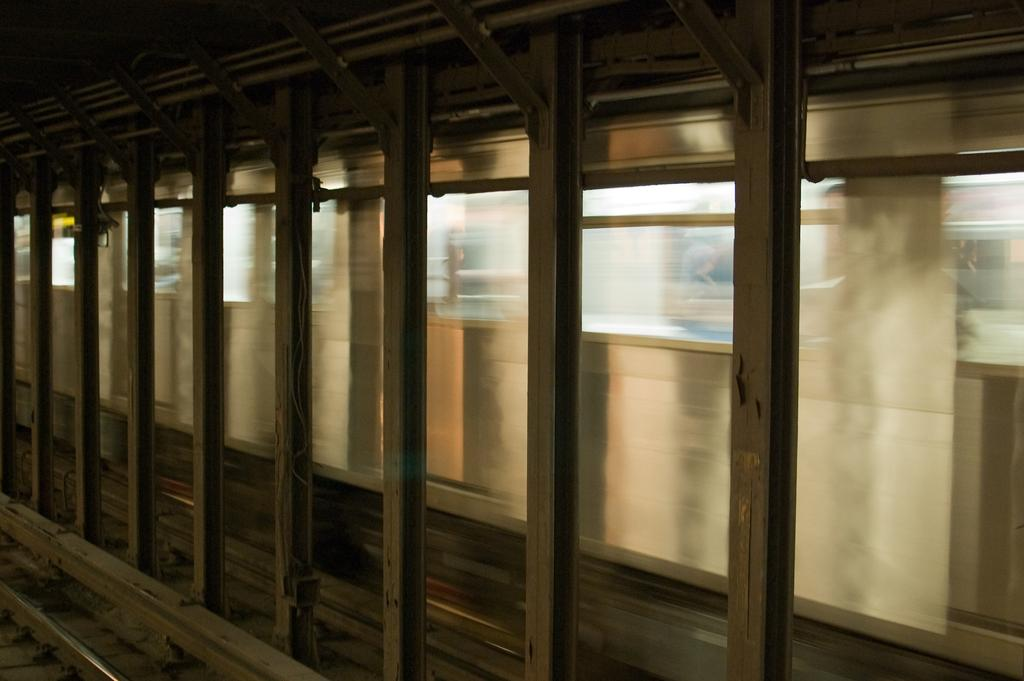What is the main structure visible in the image? There are many pillars in the image. What mode of transportation can be seen in the image? There is a train in the image. What feature do the train cars have? The train has windows. Where is the train located in the image? The train is on a railway track. What type of wine is being served on the train in the image? There is no wine or indication of any food or beverage being served on the train in the image. 